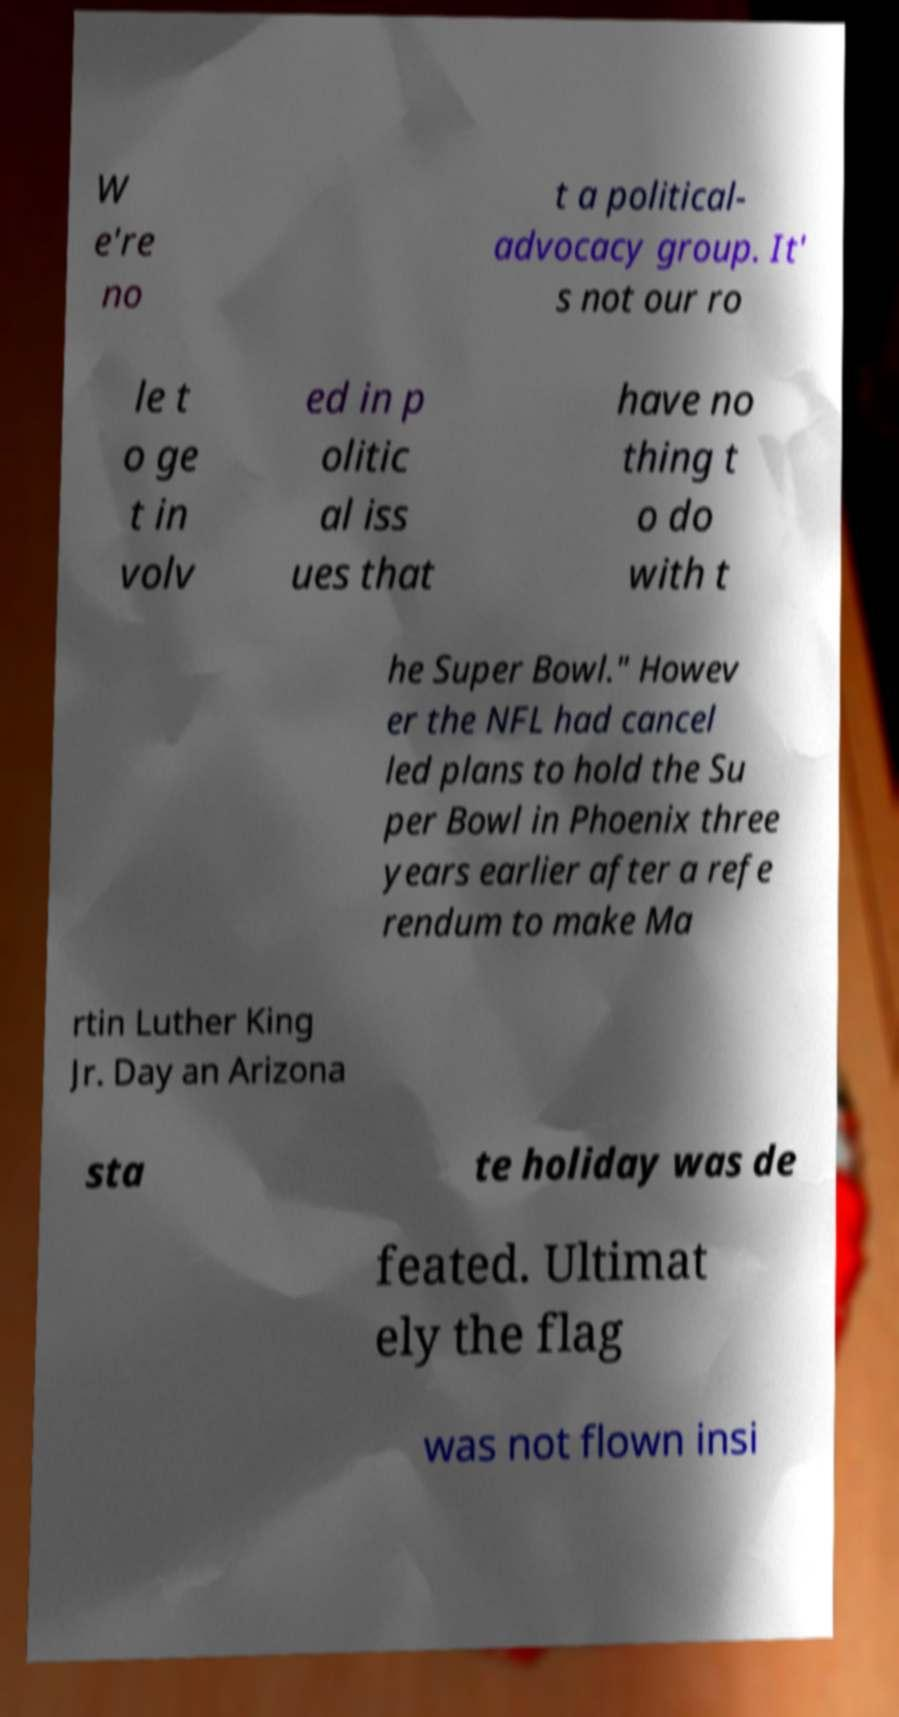Can you read and provide the text displayed in the image?This photo seems to have some interesting text. Can you extract and type it out for me? W e're no t a political- advocacy group. It' s not our ro le t o ge t in volv ed in p olitic al iss ues that have no thing t o do with t he Super Bowl." Howev er the NFL had cancel led plans to hold the Su per Bowl in Phoenix three years earlier after a refe rendum to make Ma rtin Luther King Jr. Day an Arizona sta te holiday was de feated. Ultimat ely the flag was not flown insi 